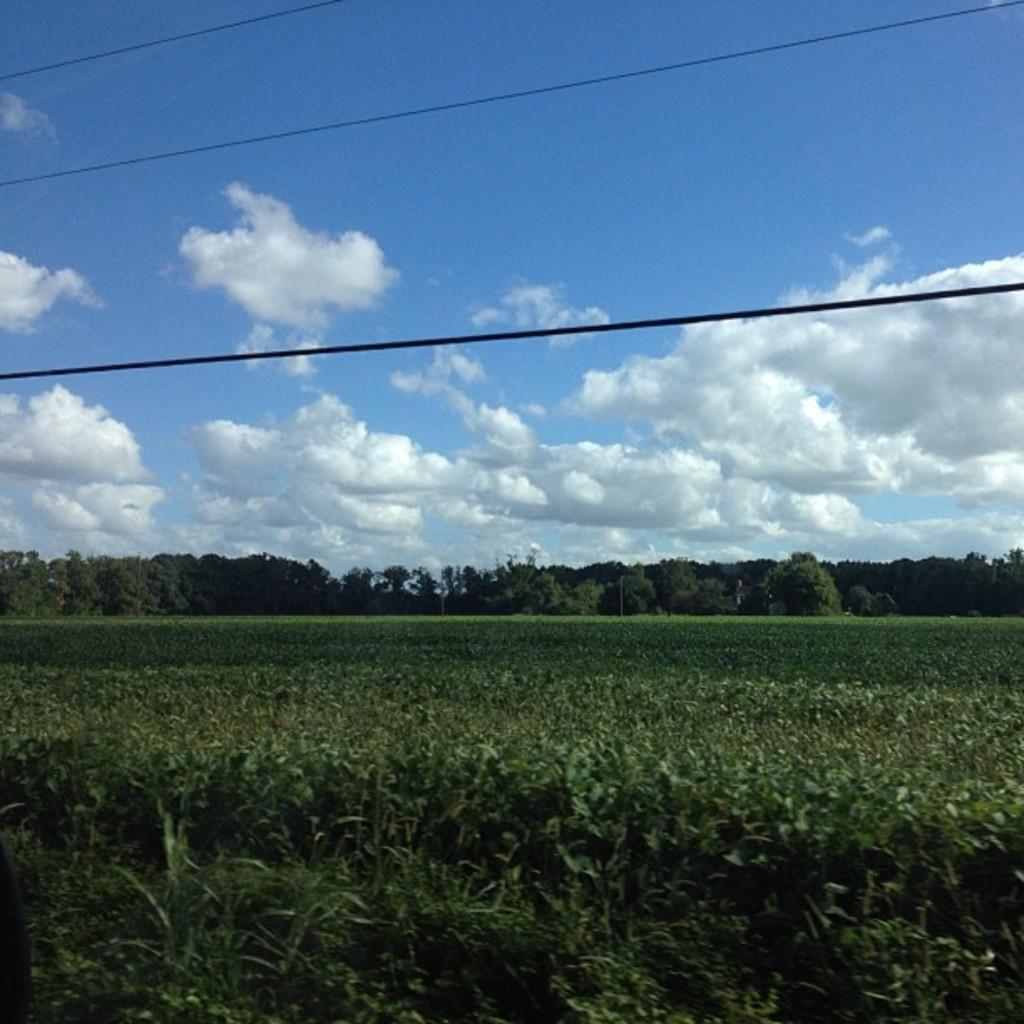Can you describe this image briefly? In this image there are trees, plants, a few cables and the sky. 